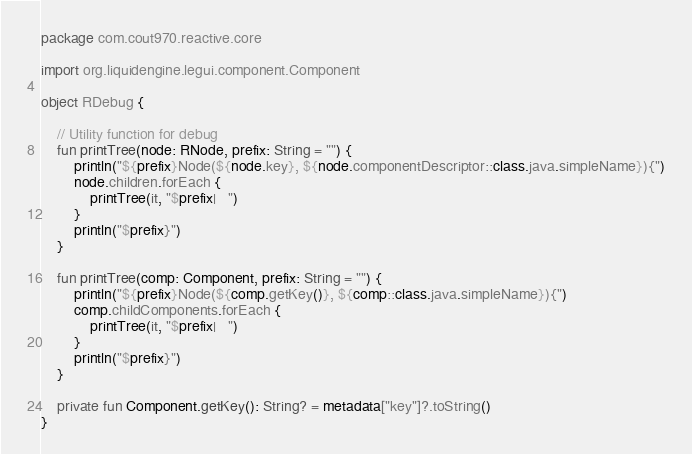<code> <loc_0><loc_0><loc_500><loc_500><_Kotlin_>package com.cout970.reactive.core

import org.liquidengine.legui.component.Component

object RDebug {

    // Utility function for debug
    fun printTree(node: RNode, prefix: String = "") {
        println("${prefix}Node(${node.key}, ${node.componentDescriptor::class.java.simpleName}){")
        node.children.forEach {
            printTree(it, "$prefix|   ")
        }
        println("$prefix}")
    }

    fun printTree(comp: Component, prefix: String = "") {
        println("${prefix}Node(${comp.getKey()}, ${comp::class.java.simpleName}){")
        comp.childComponents.forEach {
            printTree(it, "$prefix|   ")
        }
        println("$prefix}")
    }

    private fun Component.getKey(): String? = metadata["key"]?.toString()
}</code> 